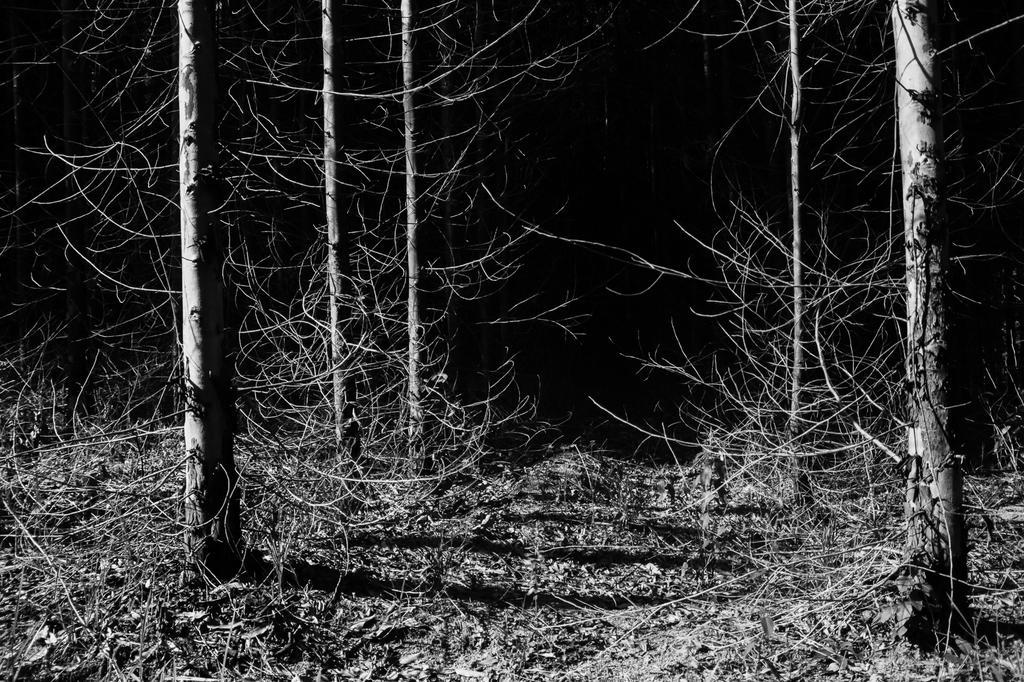In one or two sentences, can you explain what this image depicts? In this image I can see few dry trees. The image is in black and white. 